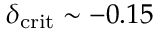<formula> <loc_0><loc_0><loc_500><loc_500>\delta _ { c r i t } \sim - 0 . 1 5</formula> 